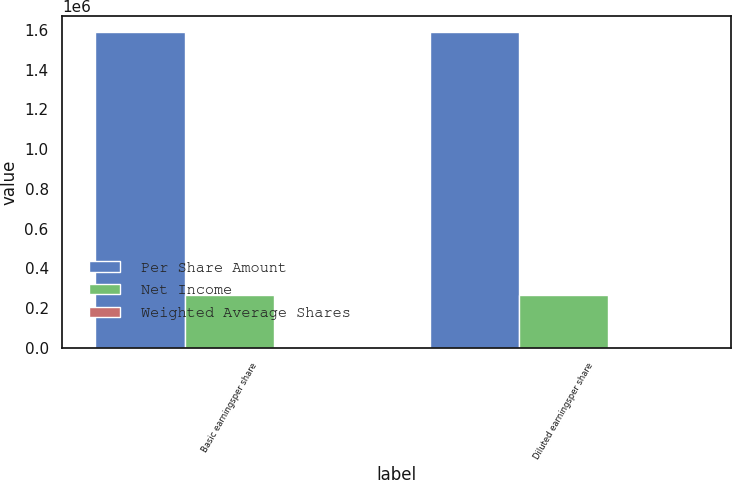Convert chart. <chart><loc_0><loc_0><loc_500><loc_500><stacked_bar_chart><ecel><fcel>Basic earningsper share<fcel>Diluted earningsper share<nl><fcel>Per Share Amount<fcel>1.58947e+06<fcel>1.58947e+06<nl><fcel>Net Income<fcel>265155<fcel>266105<nl><fcel>Weighted Average Shares<fcel>5.99<fcel>5.97<nl></chart> 